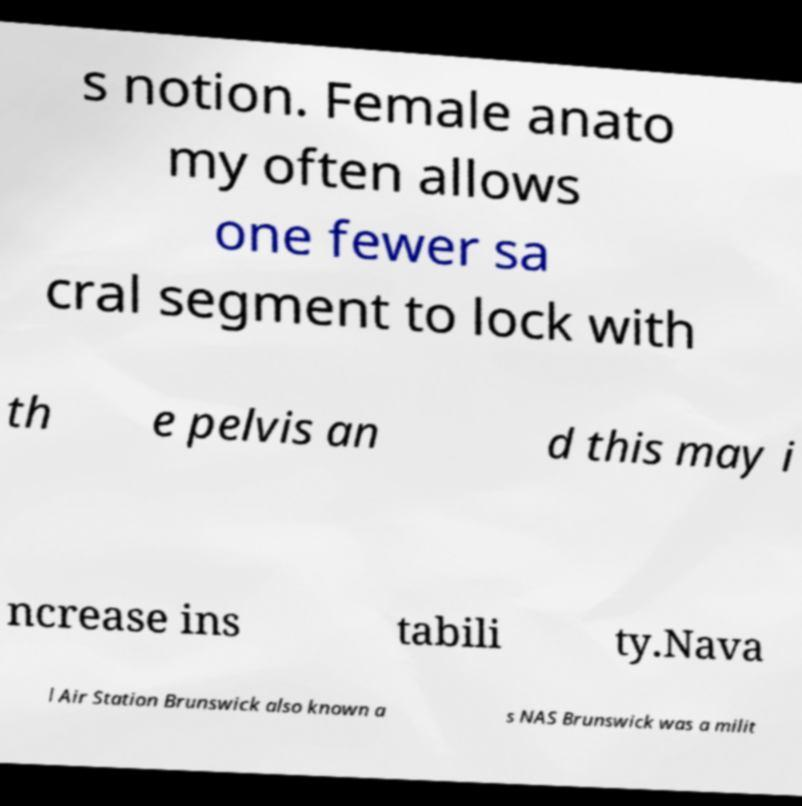Can you accurately transcribe the text from the provided image for me? s notion. Female anato my often allows one fewer sa cral segment to lock with th e pelvis an d this may i ncrease ins tabili ty.Nava l Air Station Brunswick also known a s NAS Brunswick was a milit 